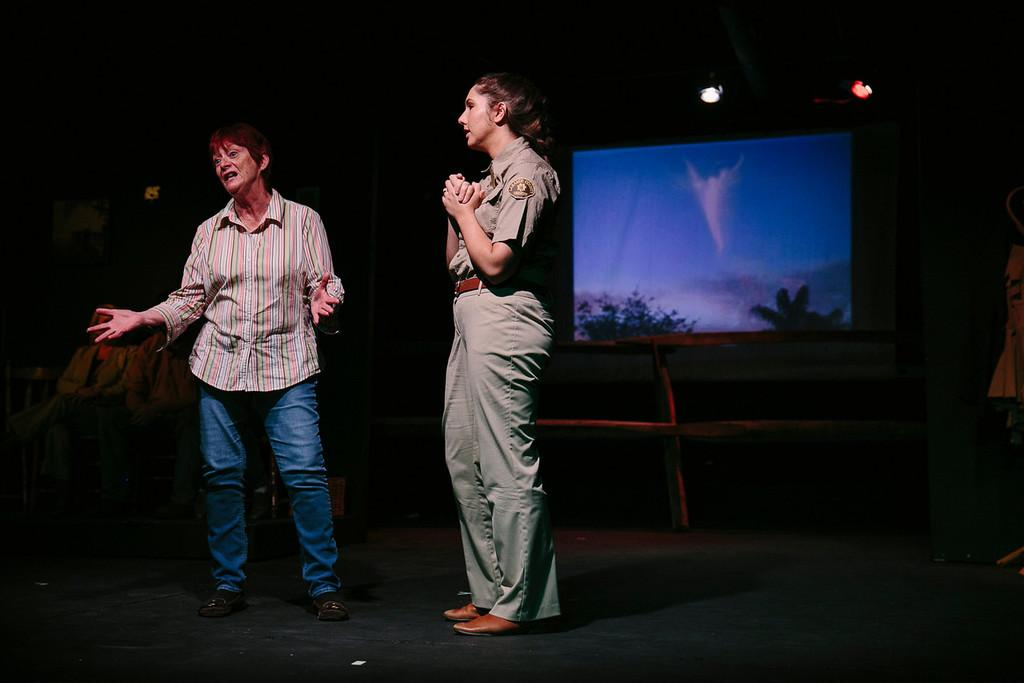What can be seen in the image? There are people standing in the image. Where are the people standing? The people are standing on the floor. What objects can be seen in the image besides the people? There are wooden poles visible in the image. What is on the wall in the image? There is a projector screen on the wall. How would you describe the lighting in the image? The background of the image is dark. What type of bread is being used for the treatment in the image? There is no bread or treatment present in the image; it features people standing on the floor with wooden poles and a projector screen on the wall. 